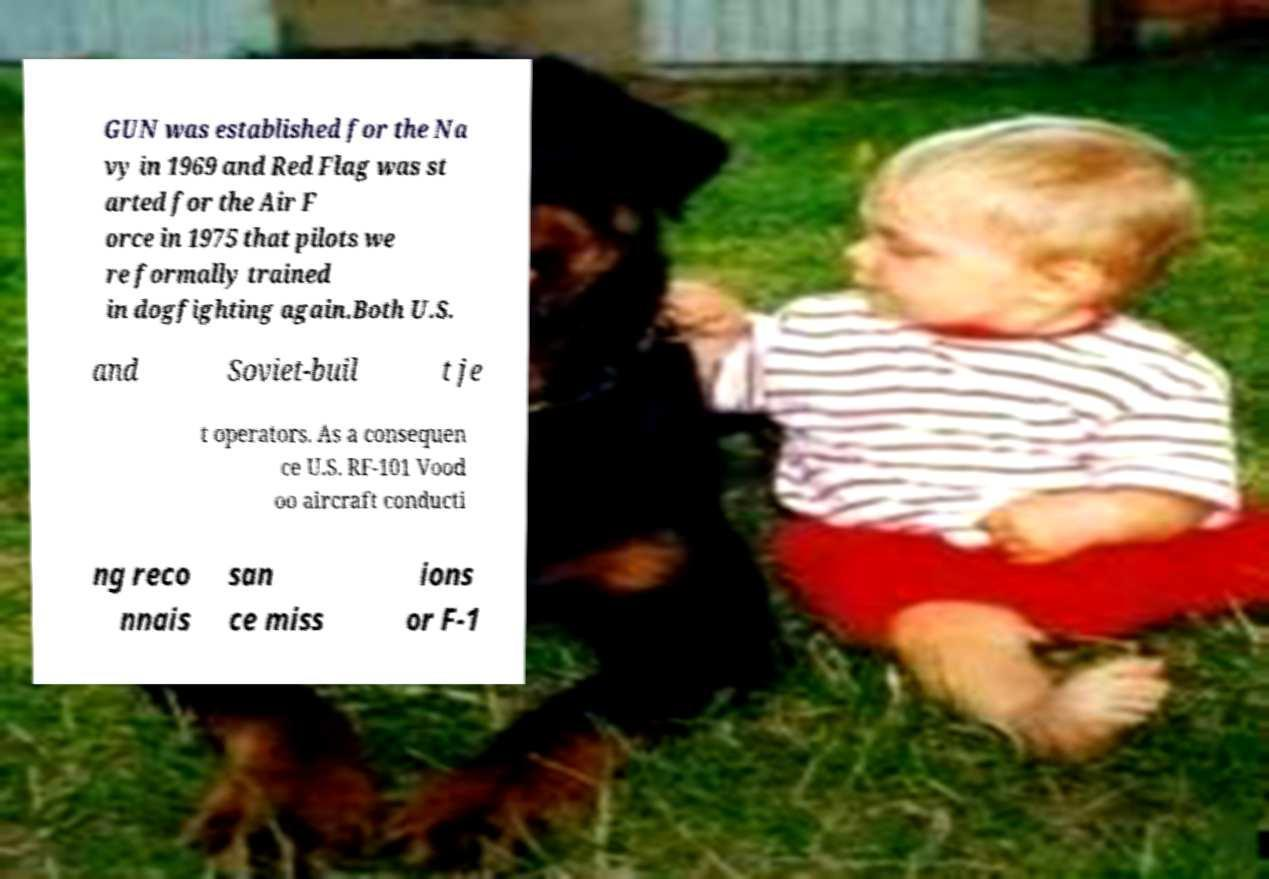For documentation purposes, I need the text within this image transcribed. Could you provide that? GUN was established for the Na vy in 1969 and Red Flag was st arted for the Air F orce in 1975 that pilots we re formally trained in dogfighting again.Both U.S. and Soviet-buil t je t operators. As a consequen ce U.S. RF-101 Vood oo aircraft conducti ng reco nnais san ce miss ions or F-1 